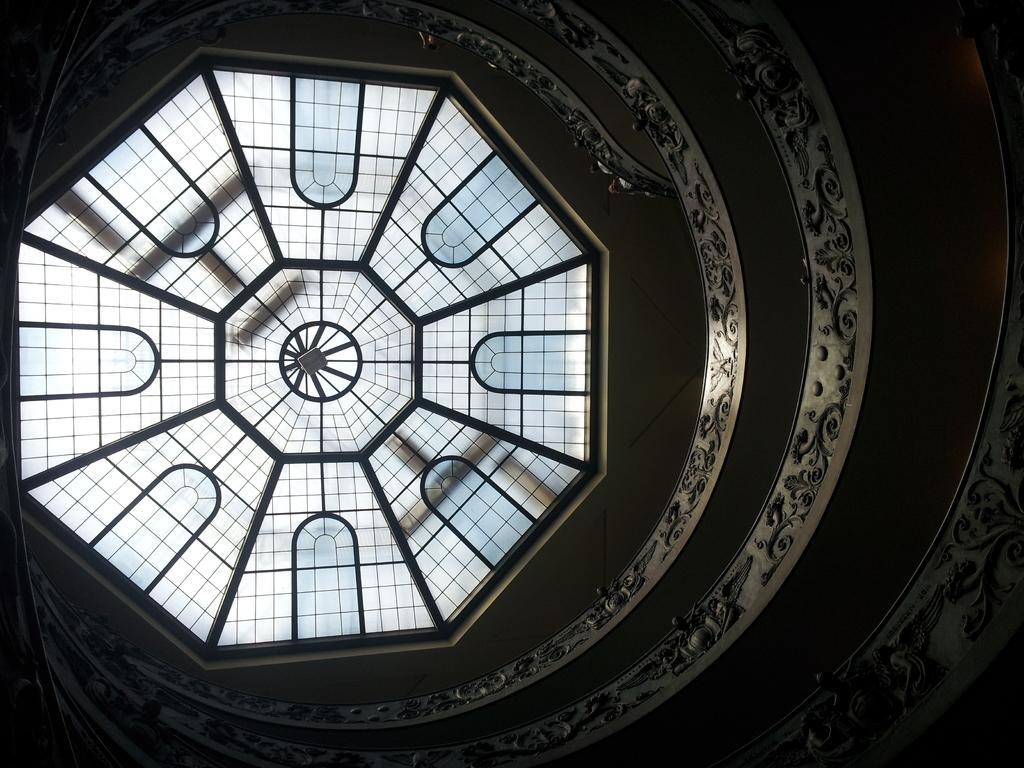What type of location is depicted in the image? The image appears to depict the interior of a museum. Can you describe any architectural features in the image? There are windows visible in the image. What type of impulse can be seen affecting the movement of the leaf in the image? There is no leaf present in the image, and therefore no impulse affecting its movement. What type of machine is visible in the image? There is no machine visible in the image; it depicts the interior of a museum. 